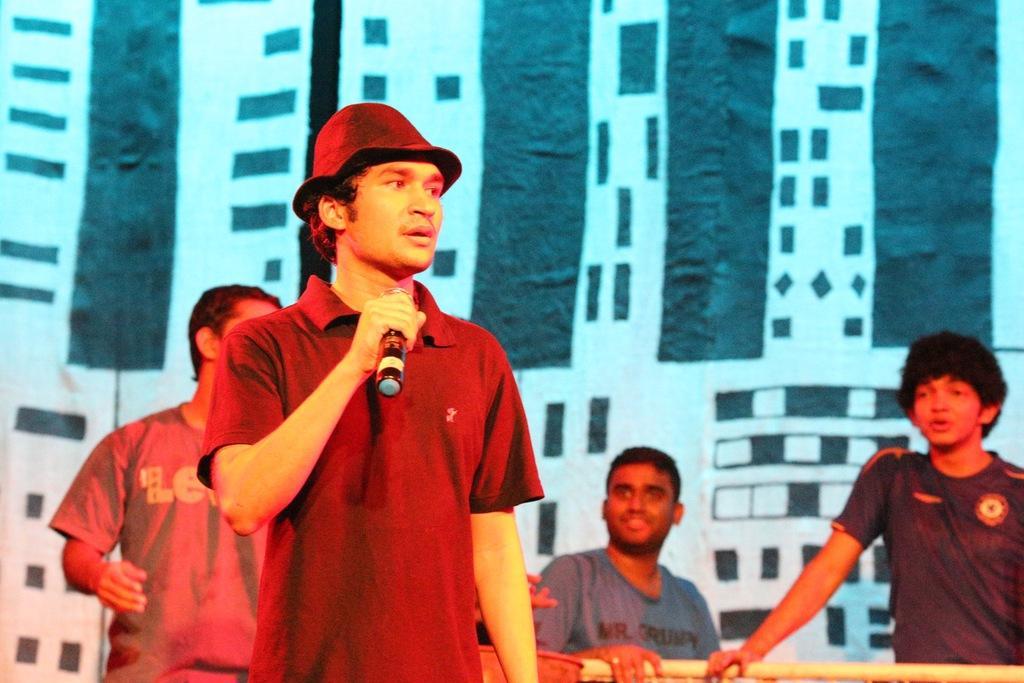How would you summarize this image in a sentence or two? In this picture we can see four men where a man wore a cap and holding a mic with his hand and beside him a man smiling. 